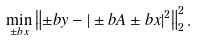<formula> <loc_0><loc_0><loc_500><loc_500>\min _ { \pm b x } \left \| \pm b y - | \pm b A \pm b x | ^ { 2 } \right \| _ { 2 } ^ { 2 } .</formula> 